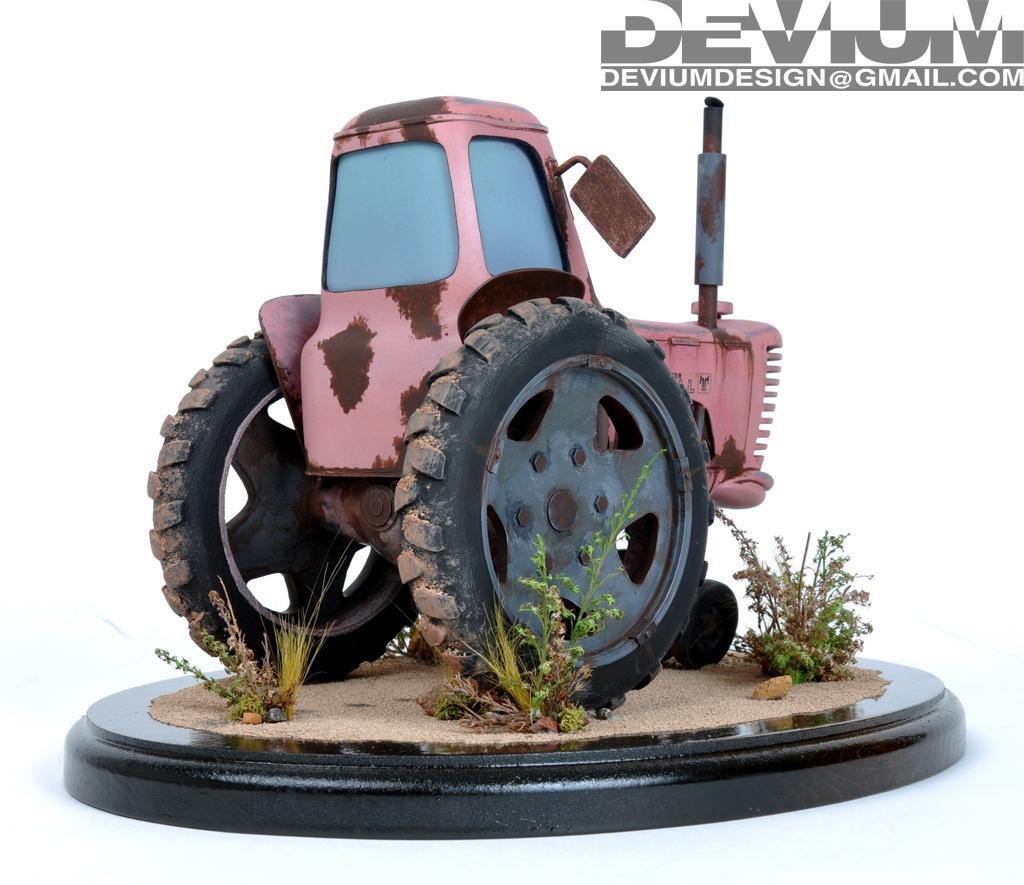In one or two sentences, can you explain what this image depicts? This picture looks like a toy tractor and I can see plants and text at the top right corner of the picture. 